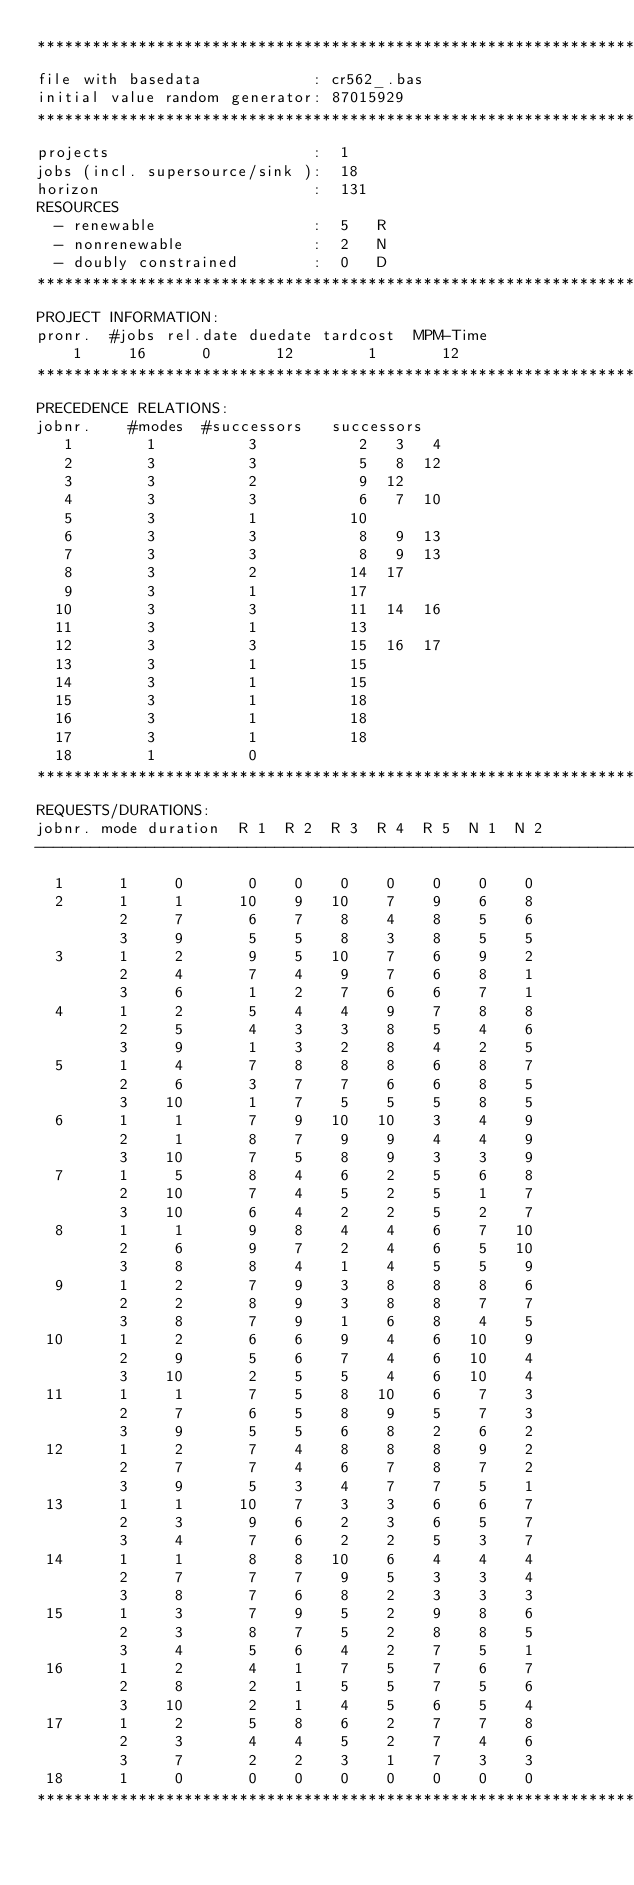Convert code to text. <code><loc_0><loc_0><loc_500><loc_500><_ObjectiveC_>************************************************************************
file with basedata            : cr562_.bas
initial value random generator: 87015929
************************************************************************
projects                      :  1
jobs (incl. supersource/sink ):  18
horizon                       :  131
RESOURCES
  - renewable                 :  5   R
  - nonrenewable              :  2   N
  - doubly constrained        :  0   D
************************************************************************
PROJECT INFORMATION:
pronr.  #jobs rel.date duedate tardcost  MPM-Time
    1     16      0       12        1       12
************************************************************************
PRECEDENCE RELATIONS:
jobnr.    #modes  #successors   successors
   1        1          3           2   3   4
   2        3          3           5   8  12
   3        3          2           9  12
   4        3          3           6   7  10
   5        3          1          10
   6        3          3           8   9  13
   7        3          3           8   9  13
   8        3          2          14  17
   9        3          1          17
  10        3          3          11  14  16
  11        3          1          13
  12        3          3          15  16  17
  13        3          1          15
  14        3          1          15
  15        3          1          18
  16        3          1          18
  17        3          1          18
  18        1          0        
************************************************************************
REQUESTS/DURATIONS:
jobnr. mode duration  R 1  R 2  R 3  R 4  R 5  N 1  N 2
------------------------------------------------------------------------
  1      1     0       0    0    0    0    0    0    0
  2      1     1      10    9   10    7    9    6    8
         2     7       6    7    8    4    8    5    6
         3     9       5    5    8    3    8    5    5
  3      1     2       9    5   10    7    6    9    2
         2     4       7    4    9    7    6    8    1
         3     6       1    2    7    6    6    7    1
  4      1     2       5    4    4    9    7    8    8
         2     5       4    3    3    8    5    4    6
         3     9       1    3    2    8    4    2    5
  5      1     4       7    8    8    8    6    8    7
         2     6       3    7    7    6    6    8    5
         3    10       1    7    5    5    5    8    5
  6      1     1       7    9   10   10    3    4    9
         2     1       8    7    9    9    4    4    9
         3    10       7    5    8    9    3    3    9
  7      1     5       8    4    6    2    5    6    8
         2    10       7    4    5    2    5    1    7
         3    10       6    4    2    2    5    2    7
  8      1     1       9    8    4    4    6    7   10
         2     6       9    7    2    4    6    5   10
         3     8       8    4    1    4    5    5    9
  9      1     2       7    9    3    8    8    8    6
         2     2       8    9    3    8    8    7    7
         3     8       7    9    1    6    8    4    5
 10      1     2       6    6    9    4    6   10    9
         2     9       5    6    7    4    6   10    4
         3    10       2    5    5    4    6   10    4
 11      1     1       7    5    8   10    6    7    3
         2     7       6    5    8    9    5    7    3
         3     9       5    5    6    8    2    6    2
 12      1     2       7    4    8    8    8    9    2
         2     7       7    4    6    7    8    7    2
         3     9       5    3    4    7    7    5    1
 13      1     1      10    7    3    3    6    6    7
         2     3       9    6    2    3    6    5    7
         3     4       7    6    2    2    5    3    7
 14      1     1       8    8   10    6    4    4    4
         2     7       7    7    9    5    3    3    4
         3     8       7    6    8    2    3    3    3
 15      1     3       7    9    5    2    9    8    6
         2     3       8    7    5    2    8    8    5
         3     4       5    6    4    2    7    5    1
 16      1     2       4    1    7    5    7    6    7
         2     8       2    1    5    5    7    5    6
         3    10       2    1    4    5    6    5    4
 17      1     2       5    8    6    2    7    7    8
         2     3       4    4    5    2    7    4    6
         3     7       2    2    3    1    7    3    3
 18      1     0       0    0    0    0    0    0    0
************************************************************************</code> 